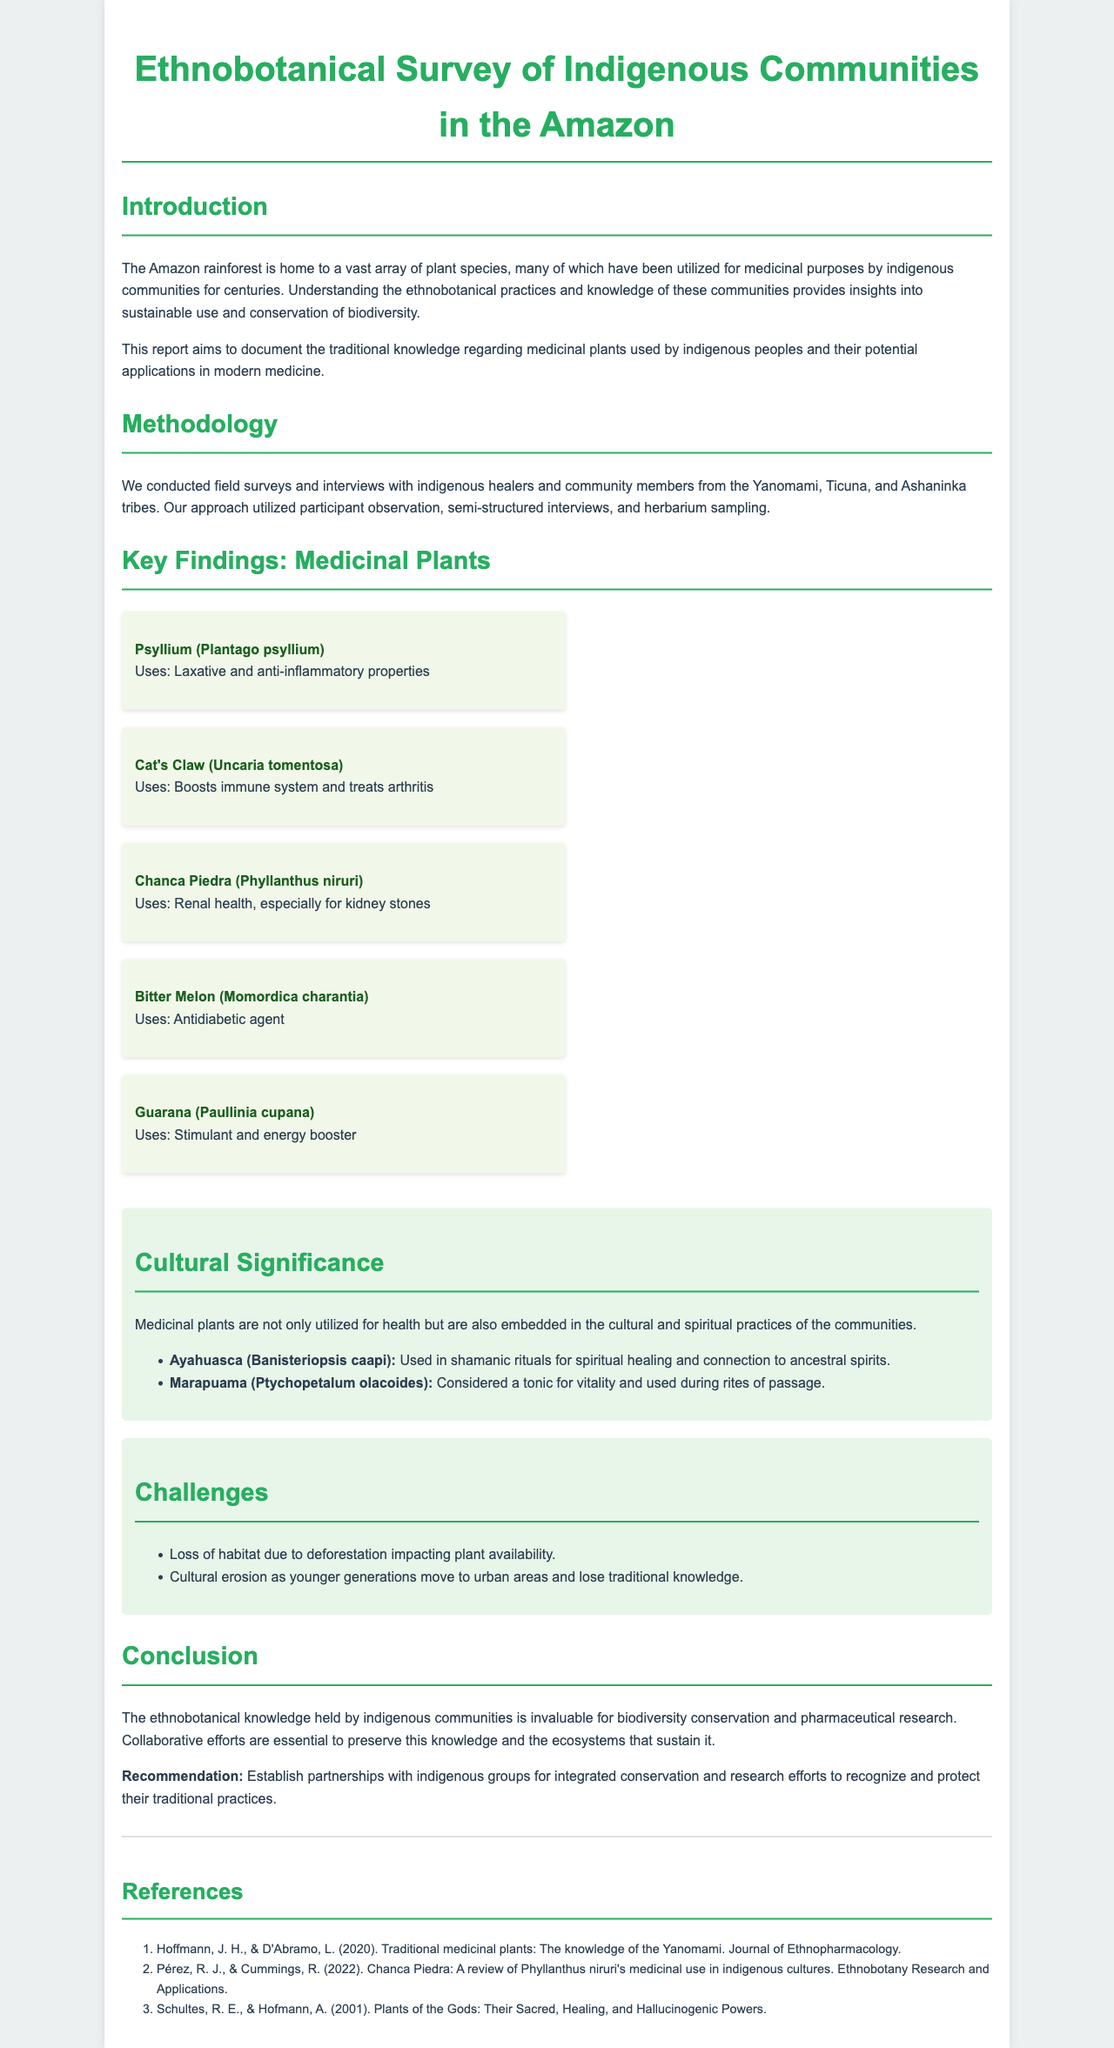What is the main focus of the report? The report aims to document the traditional knowledge regarding medicinal plants used by indigenous peoples and their potential applications in modern medicine.
Answer: Traditional knowledge regarding medicinal plants Which indigenous tribes were involved in the survey? The tribes mentioned in the document are the Yanomami, Ticuna, and Ashaninka.
Answer: Yanomami, Ticuna, Ashaninka What medicinal plant is described as a laxative? The plant known for its laxative properties is Psyllium (Plantago psyllium).
Answer: Psyllium (Plantago psyllium) What cultural practice is associated with Ayahuasca? Ayahuasca is used in shamanic rituals for spiritual healing and connection to ancestral spirits.
Answer: Shamanic rituals What is a significant challenge identified in the report? One challenge is the loss of habitat due to deforestation impacting plant availability.
Answer: Loss of habitat due to deforestation How many key findings related to medicinal plants are presented in the document? There are five key findings related to medicinal plants listed in the document.
Answer: Five What is recommended for preserving traditional practices? The recommendation is to establish partnerships with indigenous groups for integrated conservation and research efforts.
Answer: Establish partnerships with indigenous groups Which plant is noted as an antidiabetic agent? The plant recognized for its antidiabetic properties is Bitter Melon (Momordica charantia).
Answer: Bitter Melon (Momordica charantia) 